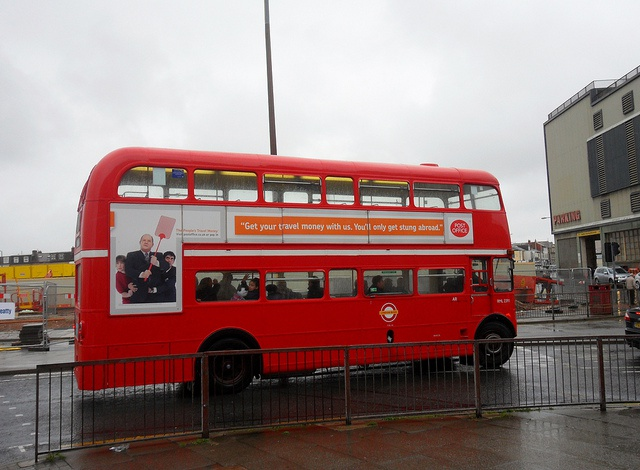Describe the objects in this image and their specific colors. I can see bus in lightgray, maroon, black, and darkgray tones, people in lightgray, black, gray, and darkgray tones, people in lightgray, black, darkgray, gray, and maroon tones, car in lightgray, black, gray, maroon, and olive tones, and people in lightgray, maroon, black, brown, and gray tones in this image. 